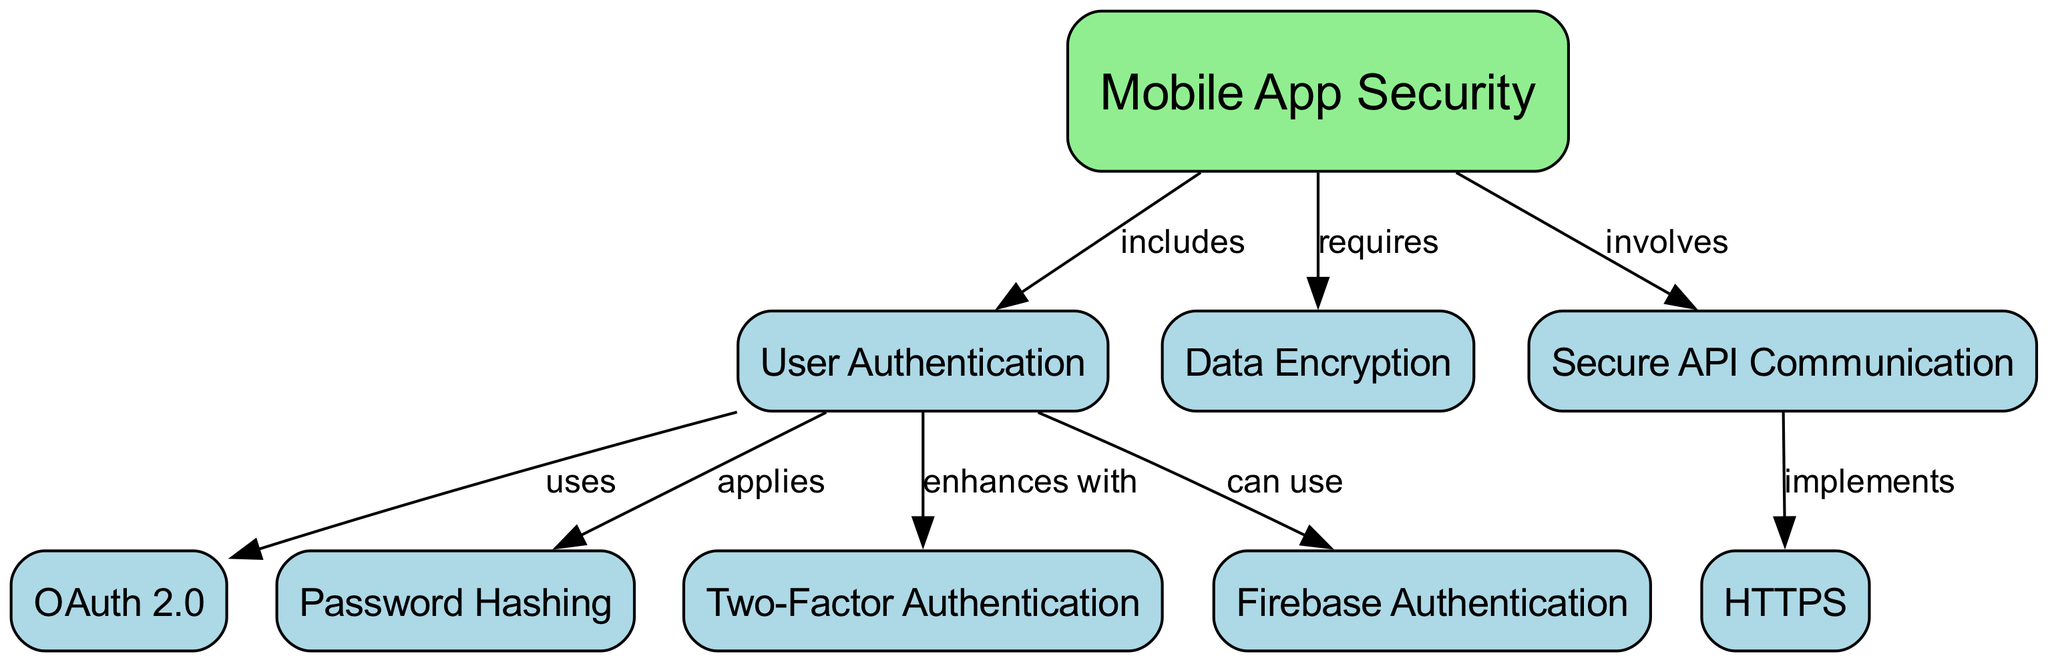What is the main topic of the concept map? The main topic is represented in the diagram by the node with ID '1', which is labeled 'Mobile App Security'.
Answer: Mobile App Security How many nodes are in the diagram? The diagram contains a total of 9 nodes, each representing a different aspect of mobile app security.
Answer: 9 What type of relationship exists between 'User Authentication' and 'OAuth 2.0'? The diagram indicates that 'User Authentication' uses 'OAuth 2.0', represented by the directed edge with the label 'uses'.
Answer: uses Which method enhances user authentication? According to the diagram, 'Two-Factor Authentication' enhances user authentication as shown by the direct relationship labeled 'enhances with'.
Answer: Two-Factor Authentication What is required for mobile app security according to the diagram? The diagram specifies that 'Data Encryption' is required for mobile app security, indicated by the edge labeled 'requires'.
Answer: Data Encryption What forms the secure API communication? The diagram shows that 'HTTPS' implements secure API communication as denoted by the relationship connecting the two nodes.
Answer: HTTPS Which authentication method can be used in mobile app security? The diagram states that 'Firebase Authentication' can be used as a method for user authentication under mobile app security practices.
Answer: Firebase Authentication How many edges are there in the diagram? The diagram features 7 edges that represent different relationships between the various nodes, linking concepts related to mobile app security.
Answer: 7 What does 'Secure API Communication' involve? The diagram denotes that 'Secure API Communication' involves 'User Authentication', which is expressed as a direct relationship labeled 'involves'.
Answer: User Authentication 